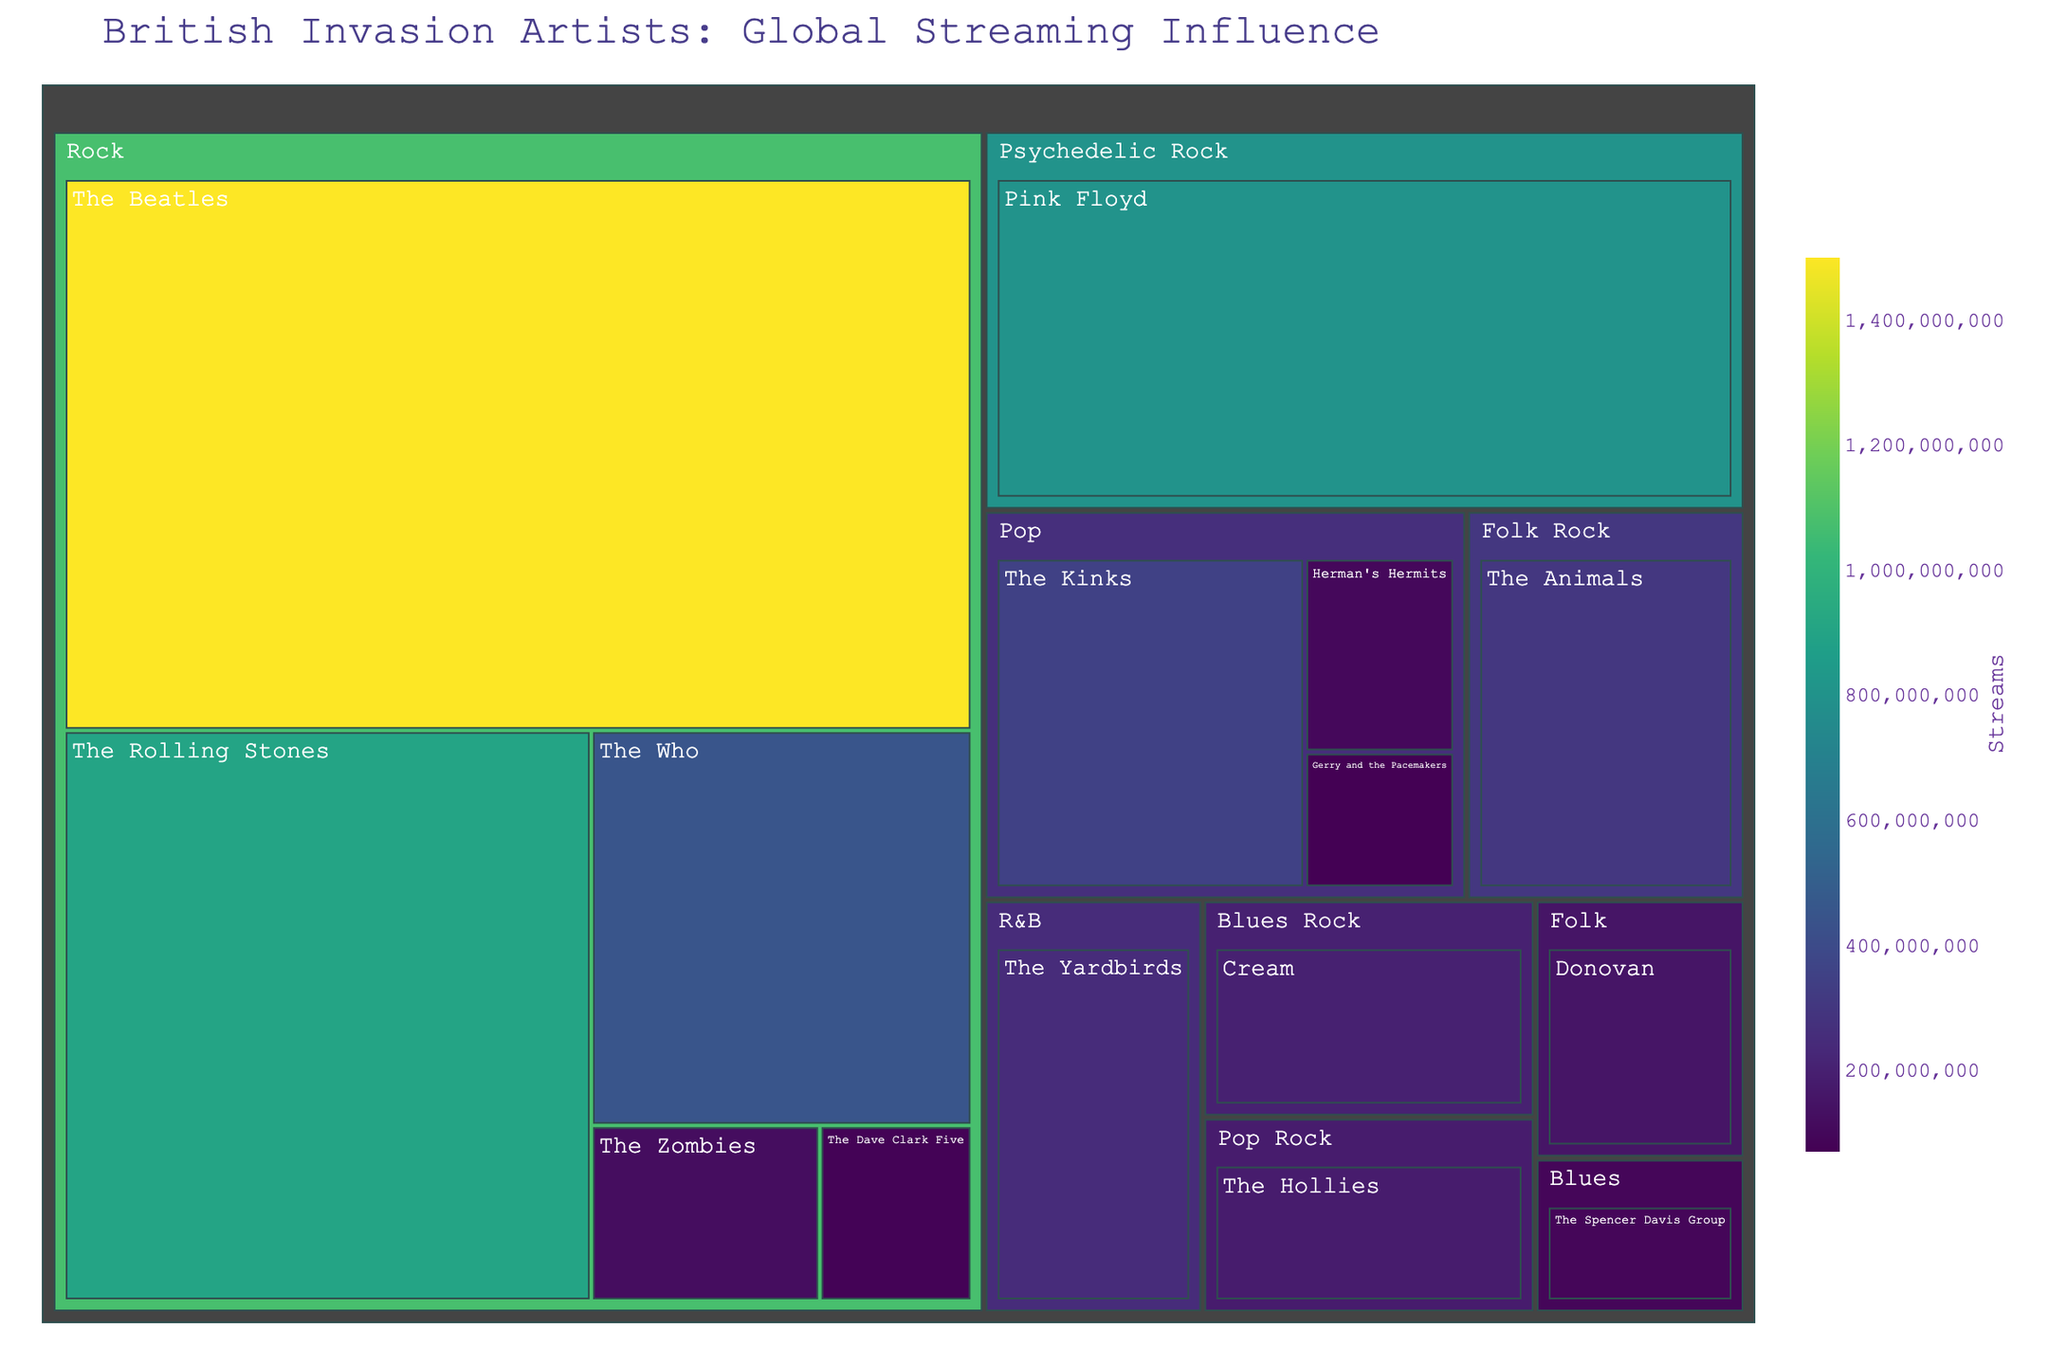What's the title of the plot? The title of the plot is located at the top and often serves as an introduction to the visual information presented. In this case, the title reads "British Invasion Artists: Global Streaming Influence".
Answer: British Invasion Artists: Global Streaming Influence Which artist in the Psychedelic Rock genre has the highest number of streams? Navigate to the Psychedelic Rock genre section of the treemap. Within this section, note the artist's name and their associated stream count. Pink Floyd appears with 800,000,000 streams.
Answer: Pink Floyd How many streams do Pop genre artists collectively have? Sum the streams of all artists listed under the Pop genre to get the total. The Kinks (350,000,000), Herman's Hermits (100,000,000), and Gerry and the Pacemakers (70,000,000) yield a total of 350,000,000 + 100,000,000 + 70,000,000.
Answer: 520,000,000 Compare the number of streams between The Beatles and The Rolling Stones. Who has more? Locate both The Beatles and The Rolling Stones under the Rock genre. The Beatles have 1,500,000,000 streams while The Rolling Stones have 900,000,000. Since 1,500,000,000 is greater than 900,000,000, The Beatles have more streams.
Answer: The Beatles Identify the artist with the least number of streams and the genre they belong to. Identify the smallest section in the treemap, which represents the artist with the lowest streams. The Dave Clark Five from the Rock genre appears with 80,000,000 streams.
Answer: The Dave Clark Five (Rock) What is the combined stream count for the Rock genre artists? Sum the stream counts of all the artists within the Rock genre. The Beatles (1,500,000,000), The Rolling Stones (900,000,000), The Who (450,000,000), The Zombies (120,000,000), and The Dave Clark Five (80,000,000) together yield: 1,500,000,000 + 900,000,000 + 450,000,000 + 120,000,000 + 80,000,000.
Answer: 3,050,000,000 Which has more streams: Psychedelic Rock's Pink Floyd or Folk Rock's The Animals? Compare the streams of Pink Floyd (800,000,000) under Psychedelic Rock with The Animals (300,000,000) under Folk Rock. Since 800,000,000 is greater than 300,000,000, Pink Floyd has more streams.
Answer: Pink Floyd How does the color intensity relate to the number of streams in the treemap? Color in the treemap typically varies with the number of streams because of the continuous color scale. Artists with higher streams like The Beatles (1,500,000,000) will appear much more saturated (darker) than those with fewer streams like Gerry and the Pacemakers (70,000,000). This relationship helps quickly identify which artists are most streamed.
Answer: Darker color indicates more streams 